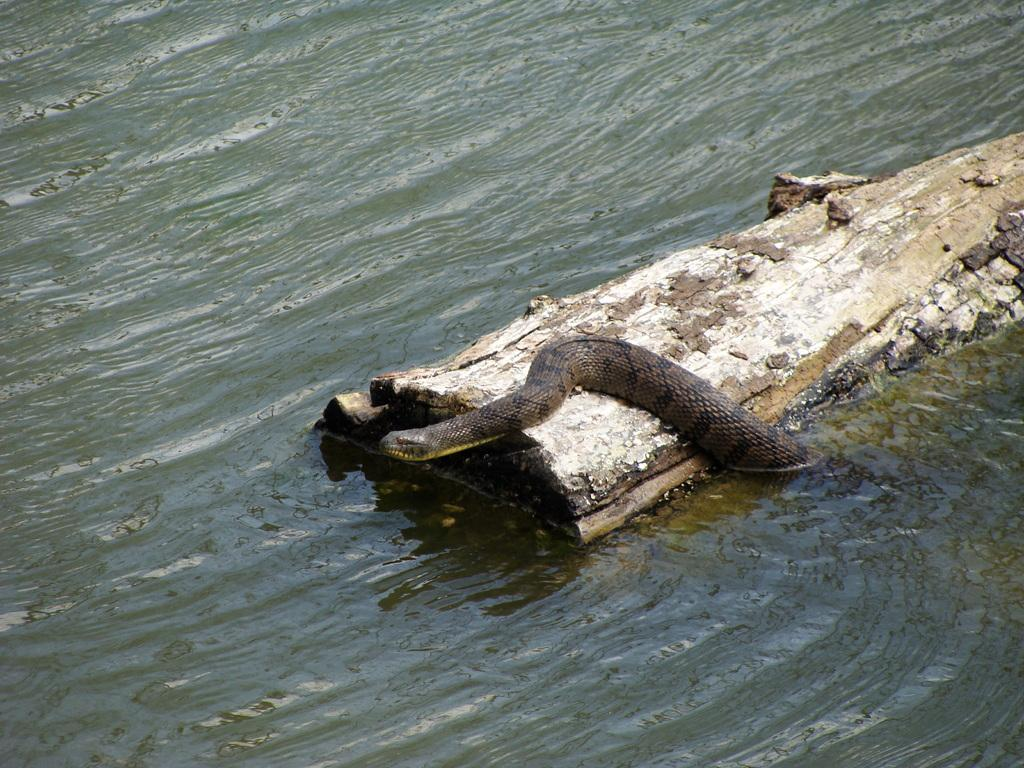What is the main object in the image? There is a wooden log in the image. What is the environment like around the log? There is a lot of water around the log. Are there any animals present in the image? Yes, there is a snake on the log. What type of teaching is happening in the image? There is no teaching activity present in the image. How does the snake shake hands with the wooden log in the image? The snake does not shake hands with the wooden log in the image; it is simply resting on the log. 